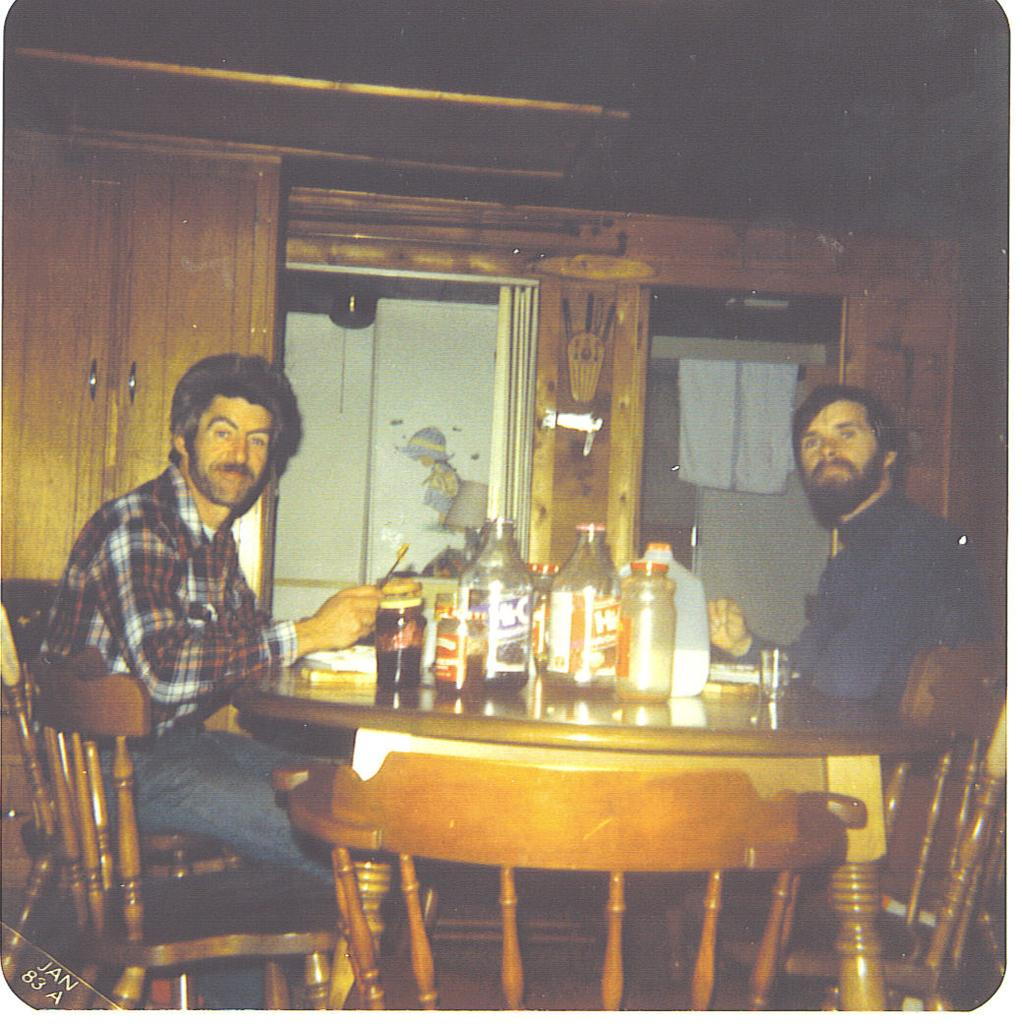How many people are in the image? There are two persons in the image. What are the two persons doing in the image? The two persons are sitting on a chair. What is present between the two persons? There is a table between the two persons. What objects can be seen on the table? There is a jar and bottles on the table. What type of flower is on the table in the image? There is no flower present on the table in the image. What is the purpose of the box on the table in the image? There is no box present on the table in the image. 